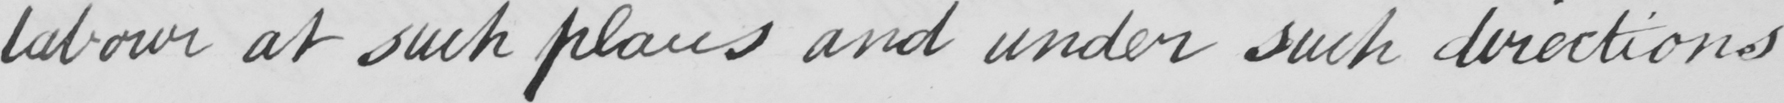What does this handwritten line say? labour at such places and under such directions 